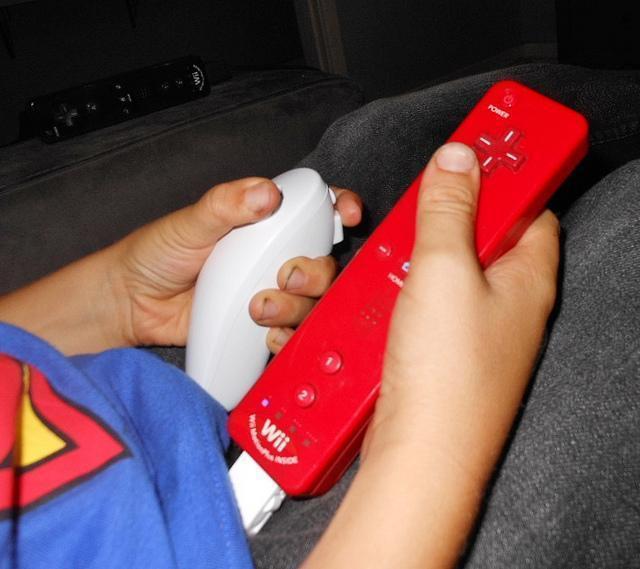How many players can play?
Make your selection from the four choices given to correctly answer the question.
Options: Three, one, four, two. Two. What was the first item manufactured by the company that makes the remote?
Choose the correct response, then elucidate: 'Answer: answer
Rationale: rationale.'
Options: Pinball machine, playing cards, slot machine, comic books. Answer: playing cards.
Rationale: Nintendo is the manufacture of the wii game console and they are know first to make playing cards until they got into making game consoles. 